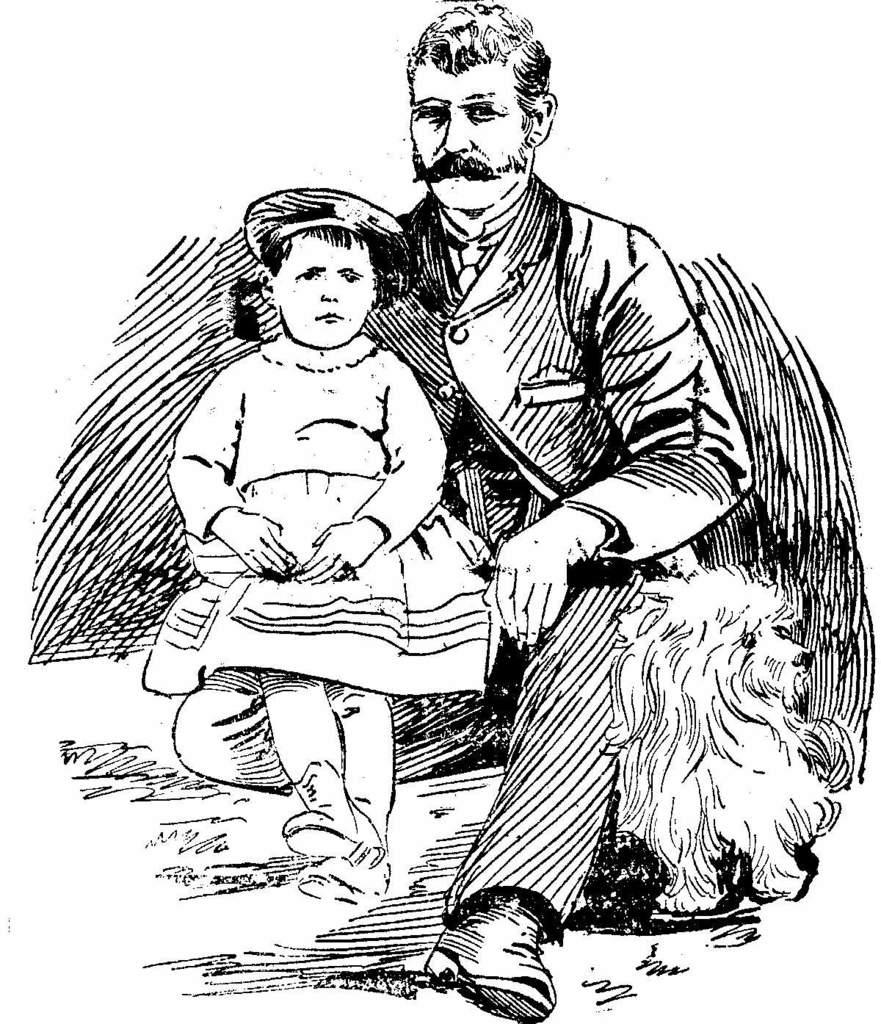What are the main subjects depicted in the image? There is a depiction of a man and a girl in the image. What is the color scheme of the image? The image is black and white in color. Are there any animals depicted in the image? Yes, there is a depiction of an animal in the image. What type of flowers are being used as payment in the image? There are no flowers or payment depicted in the image. What kind of feast is being prepared by the man and the girl in the image? There is no feast being prepared in the image; it only depicts the man, the girl, and an animal. 